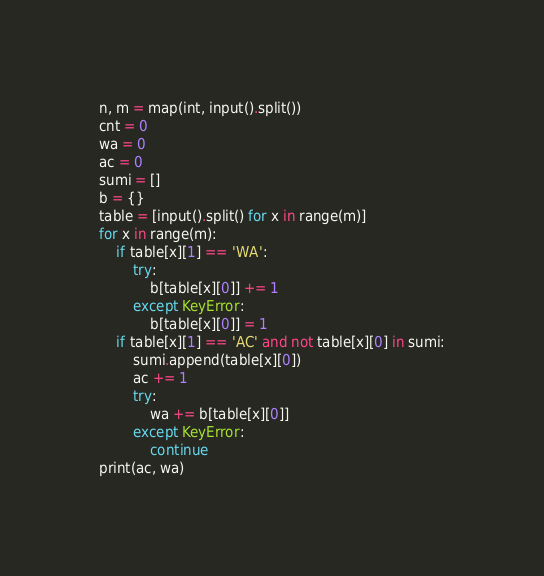Convert code to text. <code><loc_0><loc_0><loc_500><loc_500><_Python_>n, m = map(int, input().split())
cnt = 0
wa = 0
ac = 0
sumi = []
b = {}
table = [input().split() for x in range(m)]
for x in range(m):
    if table[x][1] == 'WA':
        try:
            b[table[x][0]] += 1
        except KeyError:
            b[table[x][0]] = 1
    if table[x][1] == 'AC' and not table[x][0] in sumi:
        sumi.append(table[x][0])
        ac += 1
        try:
            wa += b[table[x][0]]
        except KeyError:
            continue
print(ac, wa)
</code> 